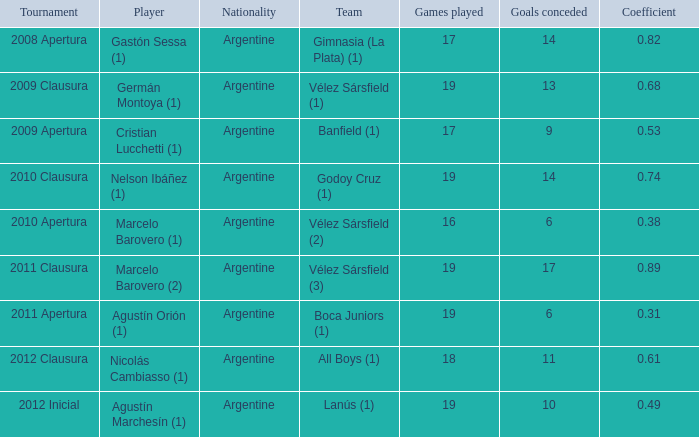What is the coefficient for agustín marchesín (1)? 0.49. 